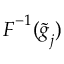Convert formula to latex. <formula><loc_0><loc_0><loc_500><loc_500>F ^ { - 1 } ( \widetilde { g } _ { j } )</formula> 